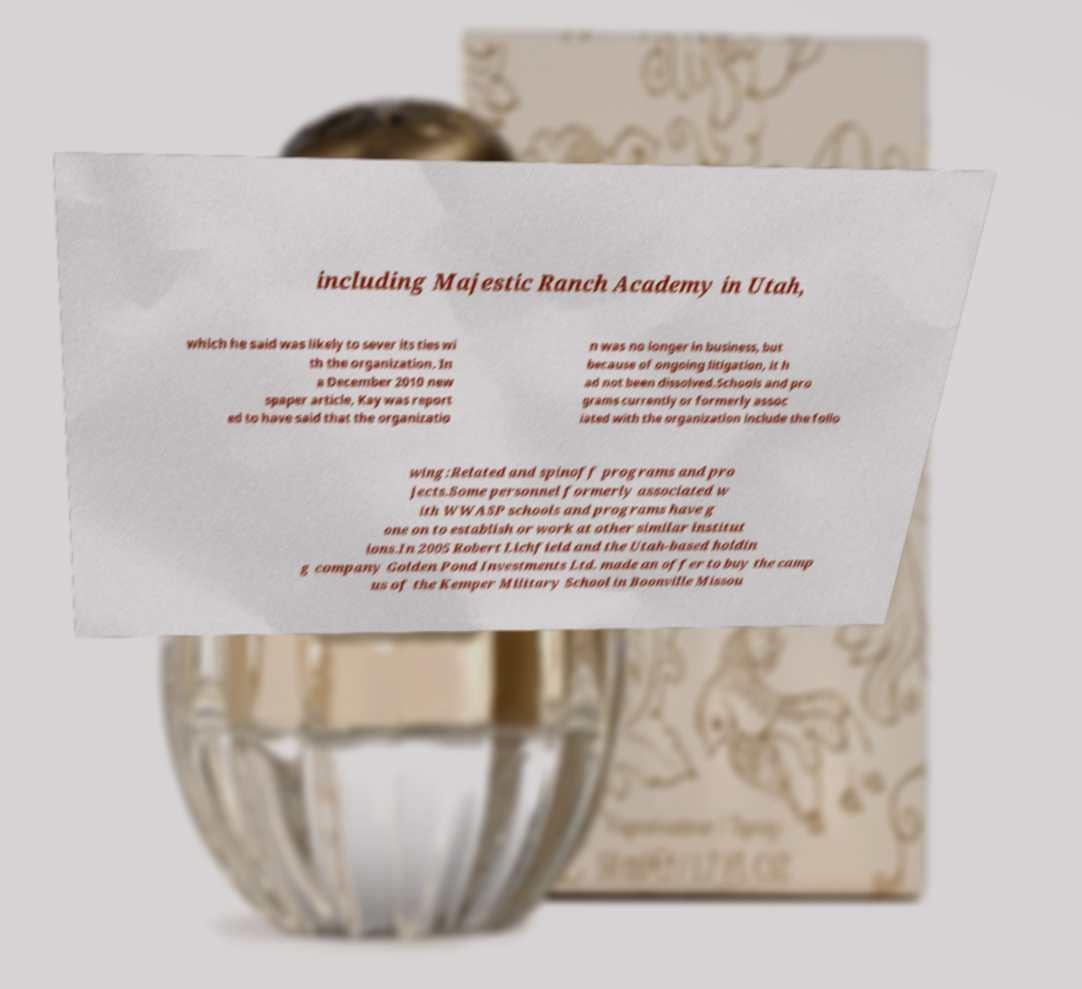Can you read and provide the text displayed in the image?This photo seems to have some interesting text. Can you extract and type it out for me? including Majestic Ranch Academy in Utah, which he said was likely to sever its ties wi th the organization. In a December 2010 new spaper article, Kay was report ed to have said that the organizatio n was no longer in business, but because of ongoing litigation, it h ad not been dissolved.Schools and pro grams currently or formerly assoc iated with the organization include the follo wing:Related and spinoff programs and pro jects.Some personnel formerly associated w ith WWASP schools and programs have g one on to establish or work at other similar institut ions.In 2005 Robert Lichfield and the Utah-based holdin g company Golden Pond Investments Ltd. made an offer to buy the camp us of the Kemper Military School in Boonville Missou 